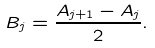Convert formula to latex. <formula><loc_0><loc_0><loc_500><loc_500>B _ { j } = \frac { A _ { j + 1 } - A _ { j } } { 2 } .</formula> 